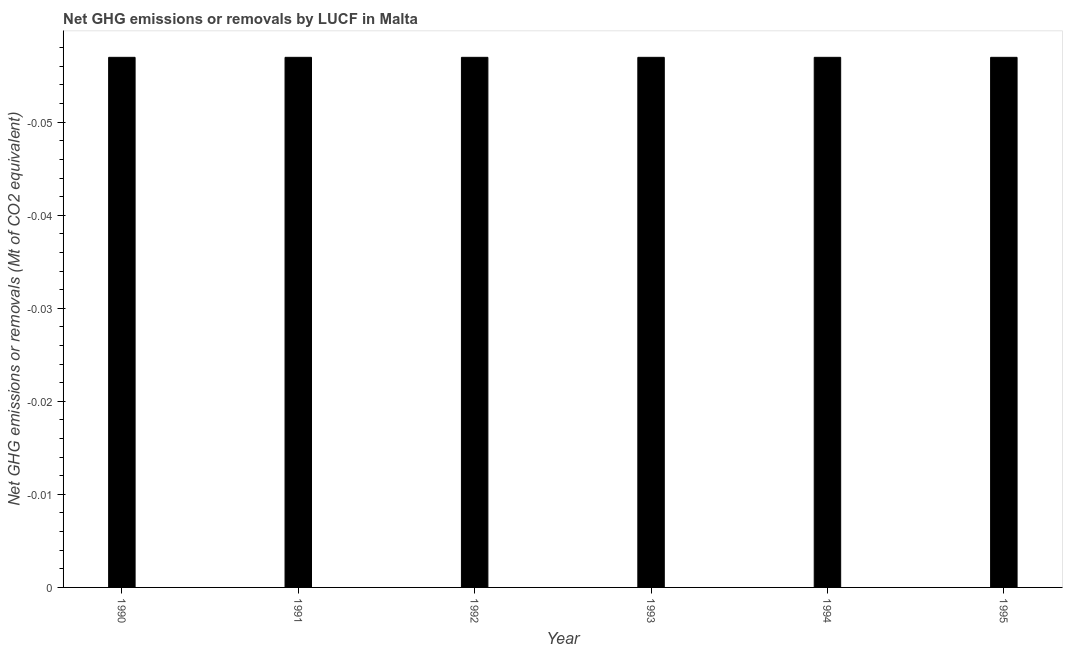Does the graph contain any zero values?
Make the answer very short. Yes. Does the graph contain grids?
Provide a short and direct response. No. What is the title of the graph?
Offer a very short reply. Net GHG emissions or removals by LUCF in Malta. What is the label or title of the Y-axis?
Keep it short and to the point. Net GHG emissions or removals (Mt of CO2 equivalent). What is the ghg net emissions or removals in 1992?
Ensure brevity in your answer.  0. Across all years, what is the minimum ghg net emissions or removals?
Your answer should be compact. 0. What is the sum of the ghg net emissions or removals?
Your answer should be compact. 0. What is the average ghg net emissions or removals per year?
Make the answer very short. 0. What is the median ghg net emissions or removals?
Your answer should be compact. 0. In how many years, is the ghg net emissions or removals greater than -0.054 Mt?
Ensure brevity in your answer.  0. How many years are there in the graph?
Your answer should be very brief. 6. What is the difference between two consecutive major ticks on the Y-axis?
Offer a very short reply. 0.01. Are the values on the major ticks of Y-axis written in scientific E-notation?
Offer a very short reply. No. What is the Net GHG emissions or removals (Mt of CO2 equivalent) of 1990?
Offer a terse response. 0. What is the Net GHG emissions or removals (Mt of CO2 equivalent) in 1993?
Offer a very short reply. 0. 